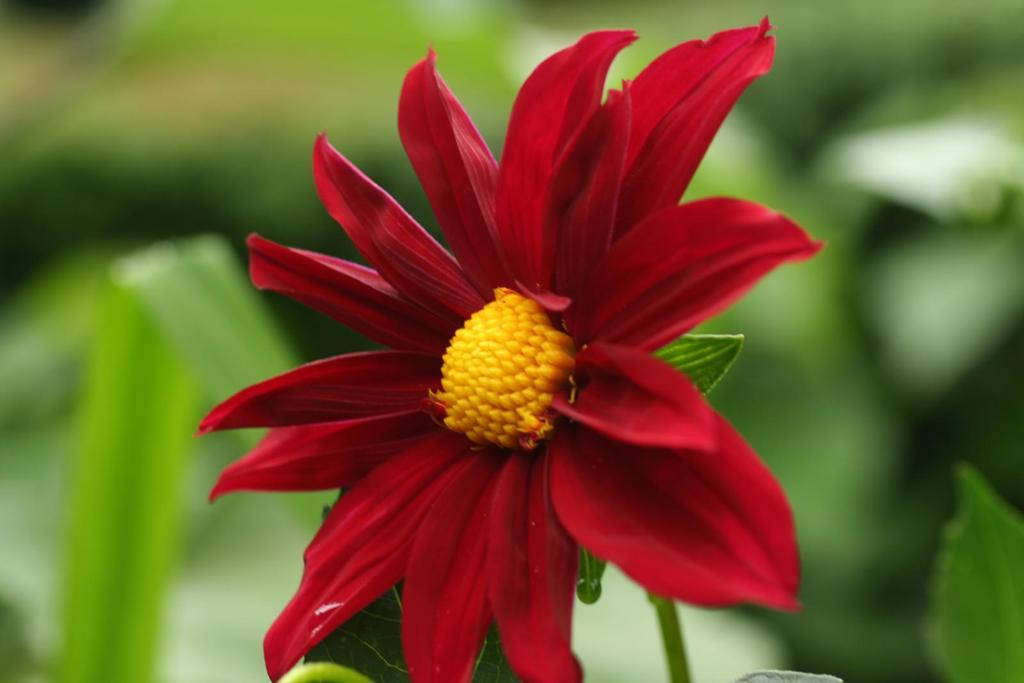What is the main subject of the image? There is a flower in the center of the image. What color is the flower? The flower is red in color. Are there any other parts of the plant visible in the image? Yes, there are leaves associated with the flower. What type of error can be seen in the image? There is no error present in the image; it features a red flower with leaves. What kind of thrill can be experienced by observing the flower in the image? The image does not convey any specific emotions or experiences, such as thrill, as it simply depicts a red flower with leaves. 